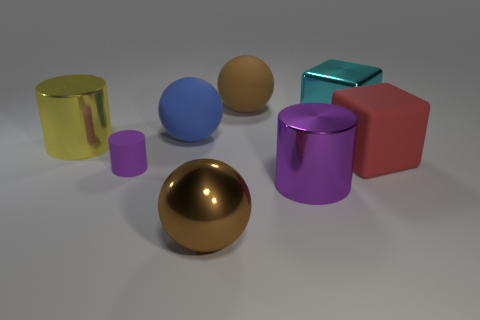Does the brown metal ball have the same size as the cyan cube?
Offer a terse response. Yes. Is the blue thing the same shape as the small matte object?
Provide a short and direct response. No. There is a yellow metal thing that is the same shape as the large purple metallic thing; what is its size?
Offer a very short reply. Large. What number of big objects are left of the purple shiny object and in front of the cyan block?
Your answer should be very brief. 3. How many other objects are there of the same size as the cyan metal block?
Provide a succinct answer. 6. Is the number of large blue matte balls that are behind the big blue thing the same as the number of big cyan rubber objects?
Ensure brevity in your answer.  Yes. Is the color of the big metallic thing that is on the left side of the blue thing the same as the large shiny cylinder on the right side of the large blue object?
Offer a terse response. No. There is a big thing that is both on the right side of the brown shiny object and in front of the tiny cylinder; what is its material?
Ensure brevity in your answer.  Metal. The tiny cylinder has what color?
Provide a short and direct response. Purple. What number of other things are there of the same shape as the small object?
Provide a succinct answer. 2. 